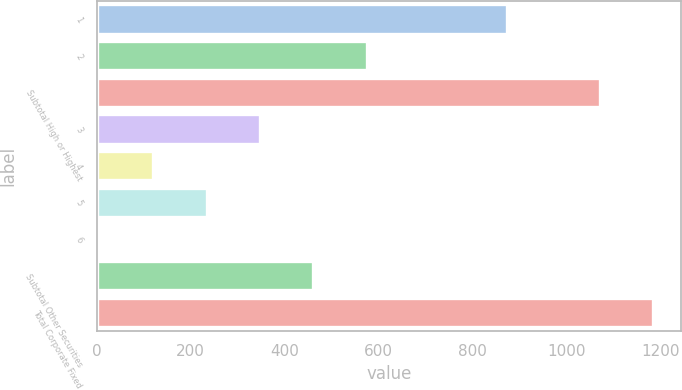<chart> <loc_0><loc_0><loc_500><loc_500><bar_chart><fcel>1<fcel>2<fcel>Subtotal High or Highest<fcel>3<fcel>4<fcel>5<fcel>6<fcel>Subtotal Other Securities<fcel>Total Corporate Fixed<nl><fcel>874<fcel>575<fcel>1072<fcel>347.8<fcel>120.6<fcel>234.2<fcel>7<fcel>461.4<fcel>1185.6<nl></chart> 